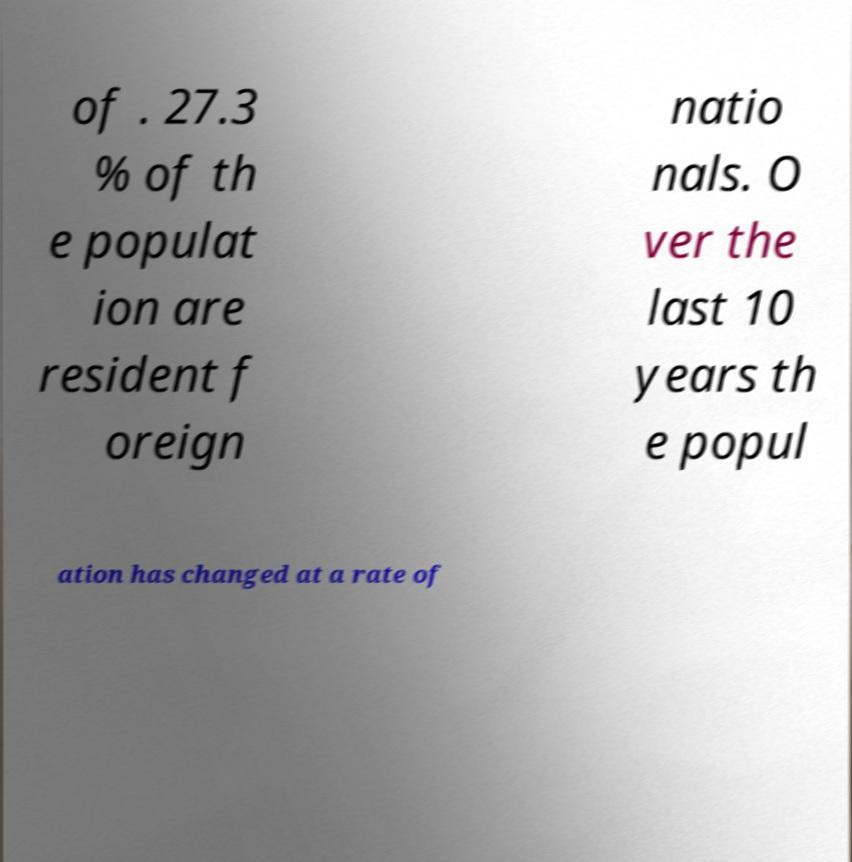Can you read and provide the text displayed in the image?This photo seems to have some interesting text. Can you extract and type it out for me? of . 27.3 % of th e populat ion are resident f oreign natio nals. O ver the last 10 years th e popul ation has changed at a rate of 